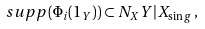<formula> <loc_0><loc_0><loc_500><loc_500>s u p p ( \Phi _ { i } ( 1 _ { Y } ) ) \subset N _ { X } Y | X _ { \sin g } \, ,</formula> 